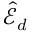<formula> <loc_0><loc_0><loc_500><loc_500>\hat { \mathcal { E } } _ { d }</formula> 